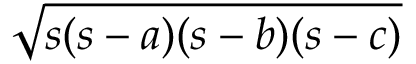<formula> <loc_0><loc_0><loc_500><loc_500>\sqrt { s ( s - a ) ( s - b ) ( s - c ) }</formula> 